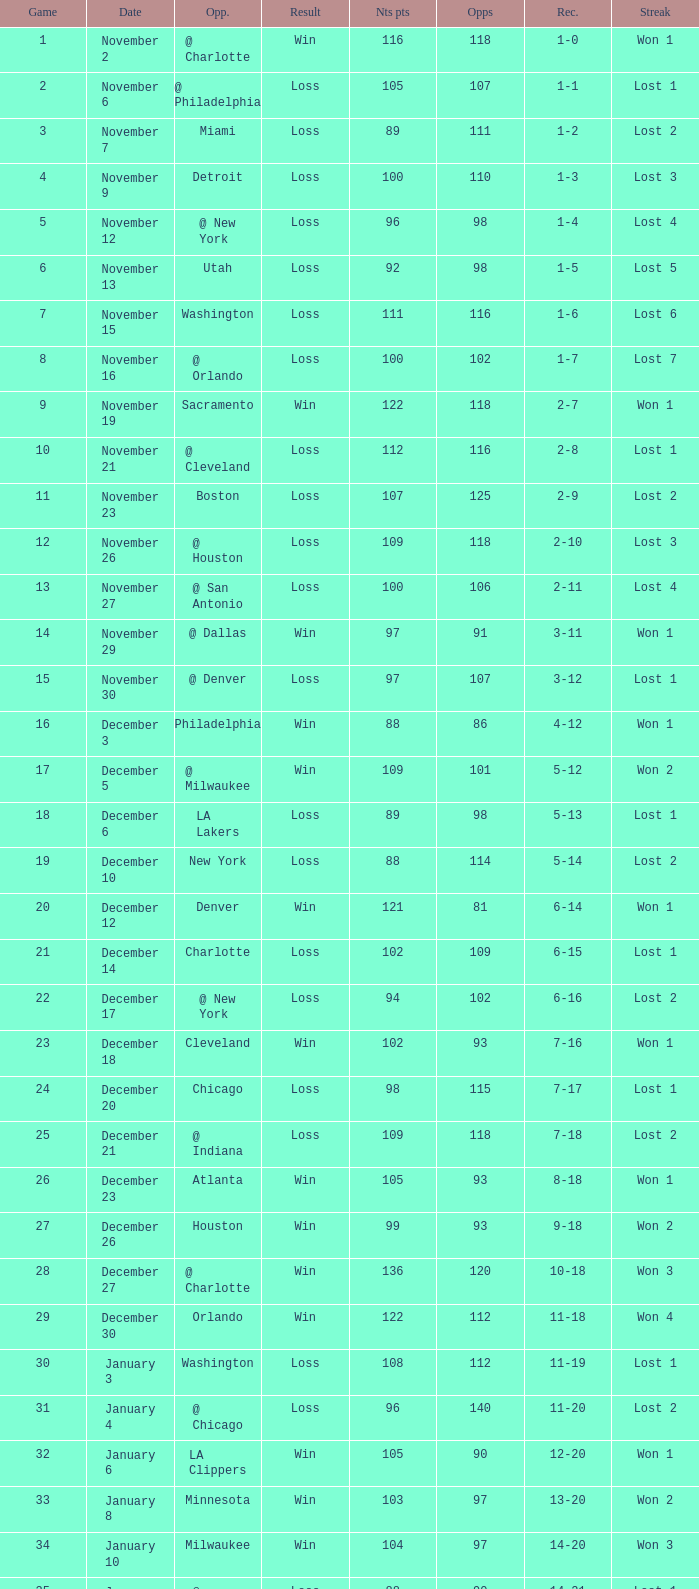How many games had fewer than 118 opponents and more than 109 net points with an opponent of Washington? 1.0. 